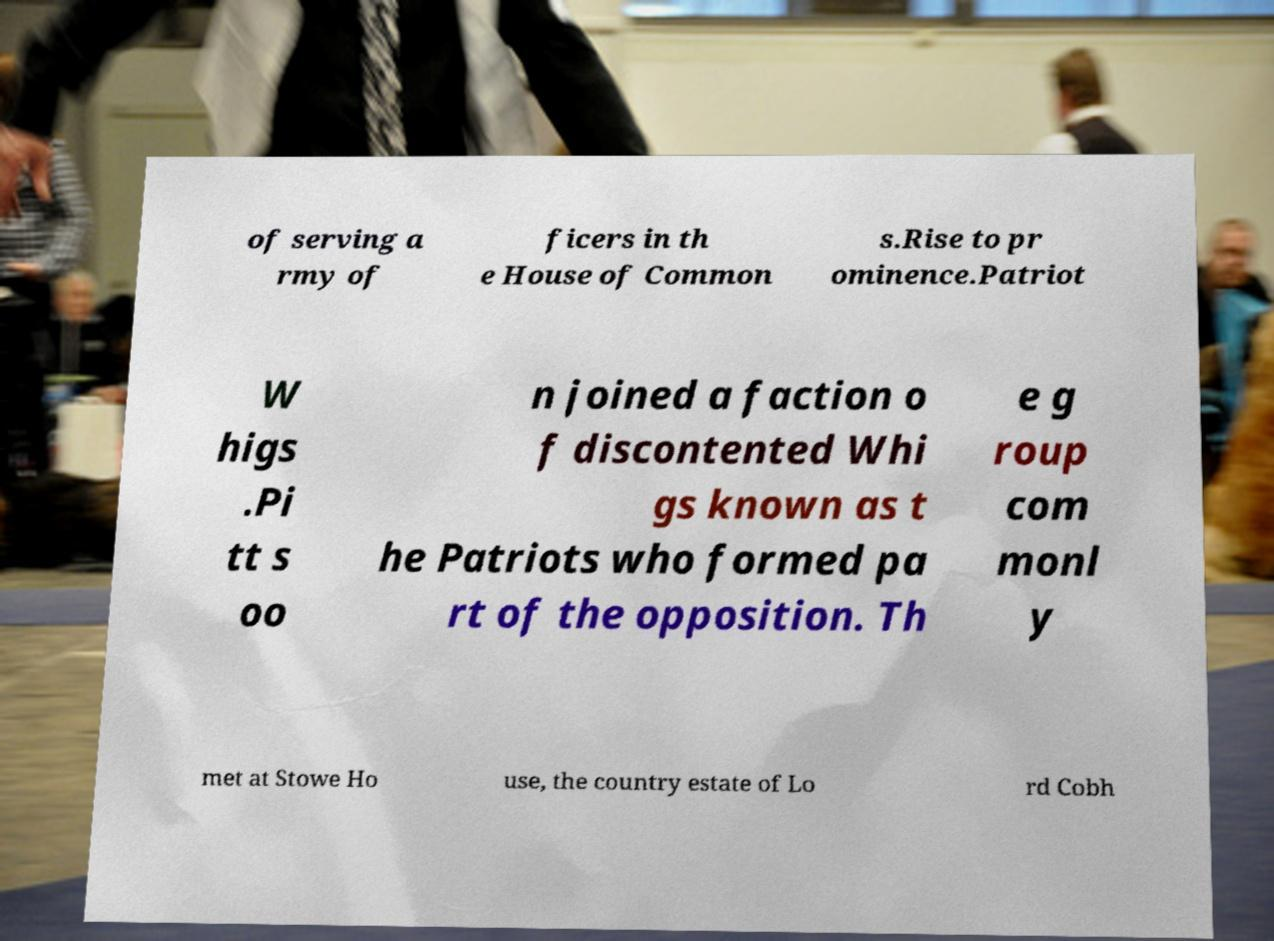Please read and relay the text visible in this image. What does it say? of serving a rmy of ficers in th e House of Common s.Rise to pr ominence.Patriot W higs .Pi tt s oo n joined a faction o f discontented Whi gs known as t he Patriots who formed pa rt of the opposition. Th e g roup com monl y met at Stowe Ho use, the country estate of Lo rd Cobh 